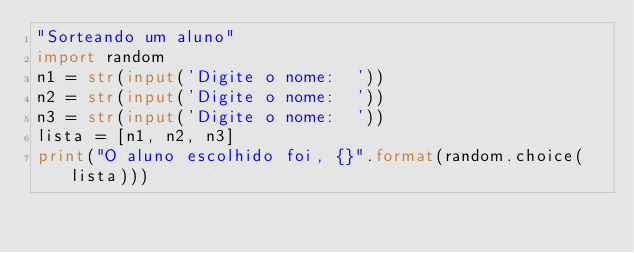Convert code to text. <code><loc_0><loc_0><loc_500><loc_500><_Python_>"Sorteando um aluno"
import random
n1 = str(input('Digite o nome:  '))
n2 = str(input('Digite o nome:  '))
n3 = str(input('Digite o nome:  '))
lista = [n1, n2, n3]
print("O aluno escolhido foi, {}".format(random.choice(lista)))

</code> 